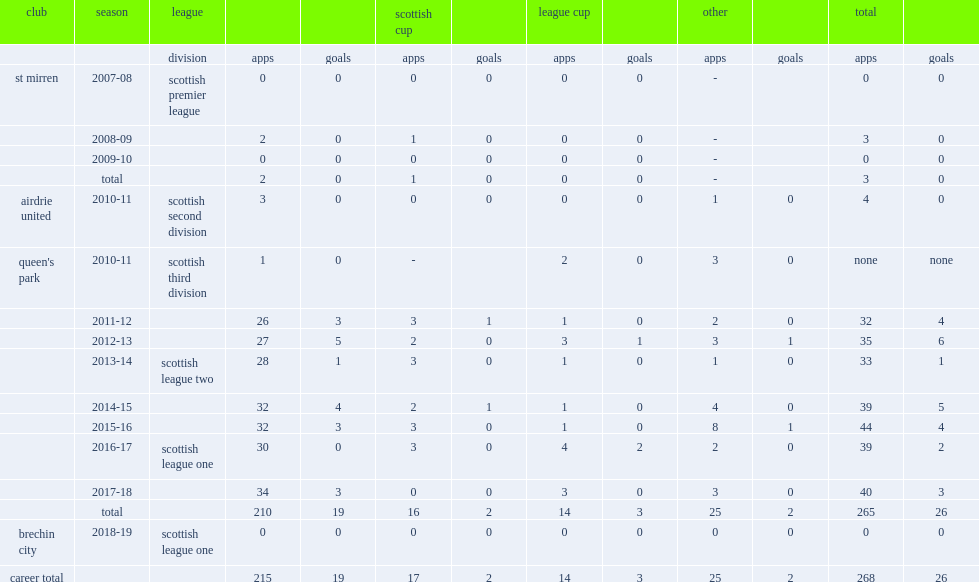Could you help me parse every detail presented in this table? {'header': ['club', 'season', 'league', '', '', 'scottish cup', '', 'league cup', '', 'other', '', 'total', ''], 'rows': [['', '', 'division', 'apps', 'goals', 'apps', 'goals', 'apps', 'goals', 'apps', 'goals', 'apps', 'goals'], ['st mirren', '2007-08', 'scottish premier league', '0', '0', '0', '0', '0', '0', '-', '', '0', '0'], ['', '2008-09', '', '2', '0', '1', '0', '0', '0', '-', '', '3', '0'], ['', '2009-10', '', '0', '0', '0', '0', '0', '0', '-', '', '0', '0'], ['', 'total', '', '2', '0', '1', '0', '0', '0', '-', '', '3', '0'], ['airdrie united', '2010-11', 'scottish second division', '3', '0', '0', '0', '0', '0', '1', '0', '4', '0'], ["queen's park", '2010-11', 'scottish third division', '1', '0', '-', '', '2', '0', '3', '0', 'none', 'none'], ['', '2011-12', '', '26', '3', '3', '1', '1', '0', '2', '0', '32', '4'], ['', '2012-13', '', '27', '5', '2', '0', '3', '1', '3', '1', '35', '6'], ['', '2013-14', 'scottish league two', '28', '1', '3', '0', '1', '0', '1', '0', '33', '1'], ['', '2014-15', '', '32', '4', '2', '1', '1', '0', '4', '0', '39', '5'], ['', '2015-16', '', '32', '3', '3', '0', '1', '0', '8', '1', '44', '4'], ['', '2016-17', 'scottish league one', '30', '0', '3', '0', '4', '2', '2', '0', '39', '2'], ['', '2017-18', '', '34', '3', '0', '0', '3', '0', '3', '0', '40', '3'], ['', 'total', '', '210', '19', '16', '2', '14', '3', '25', '2', '265', '26'], ['brechin city', '2018-19', 'scottish league one', '0', '0', '0', '0', '0', '0', '0', '0', '0', '0'], ['career total', '', '', '215', '19', '17', '2', '14', '3', '25', '2', '268', '26']]} How many goals did burns score totally? 26.0. 